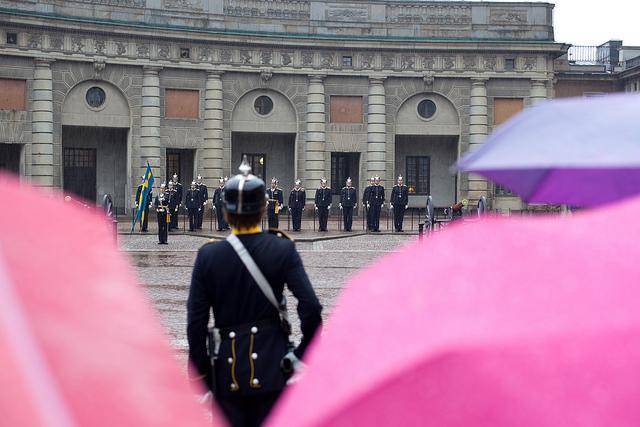How many umbrellas are there?
Give a very brief answer. 3. 